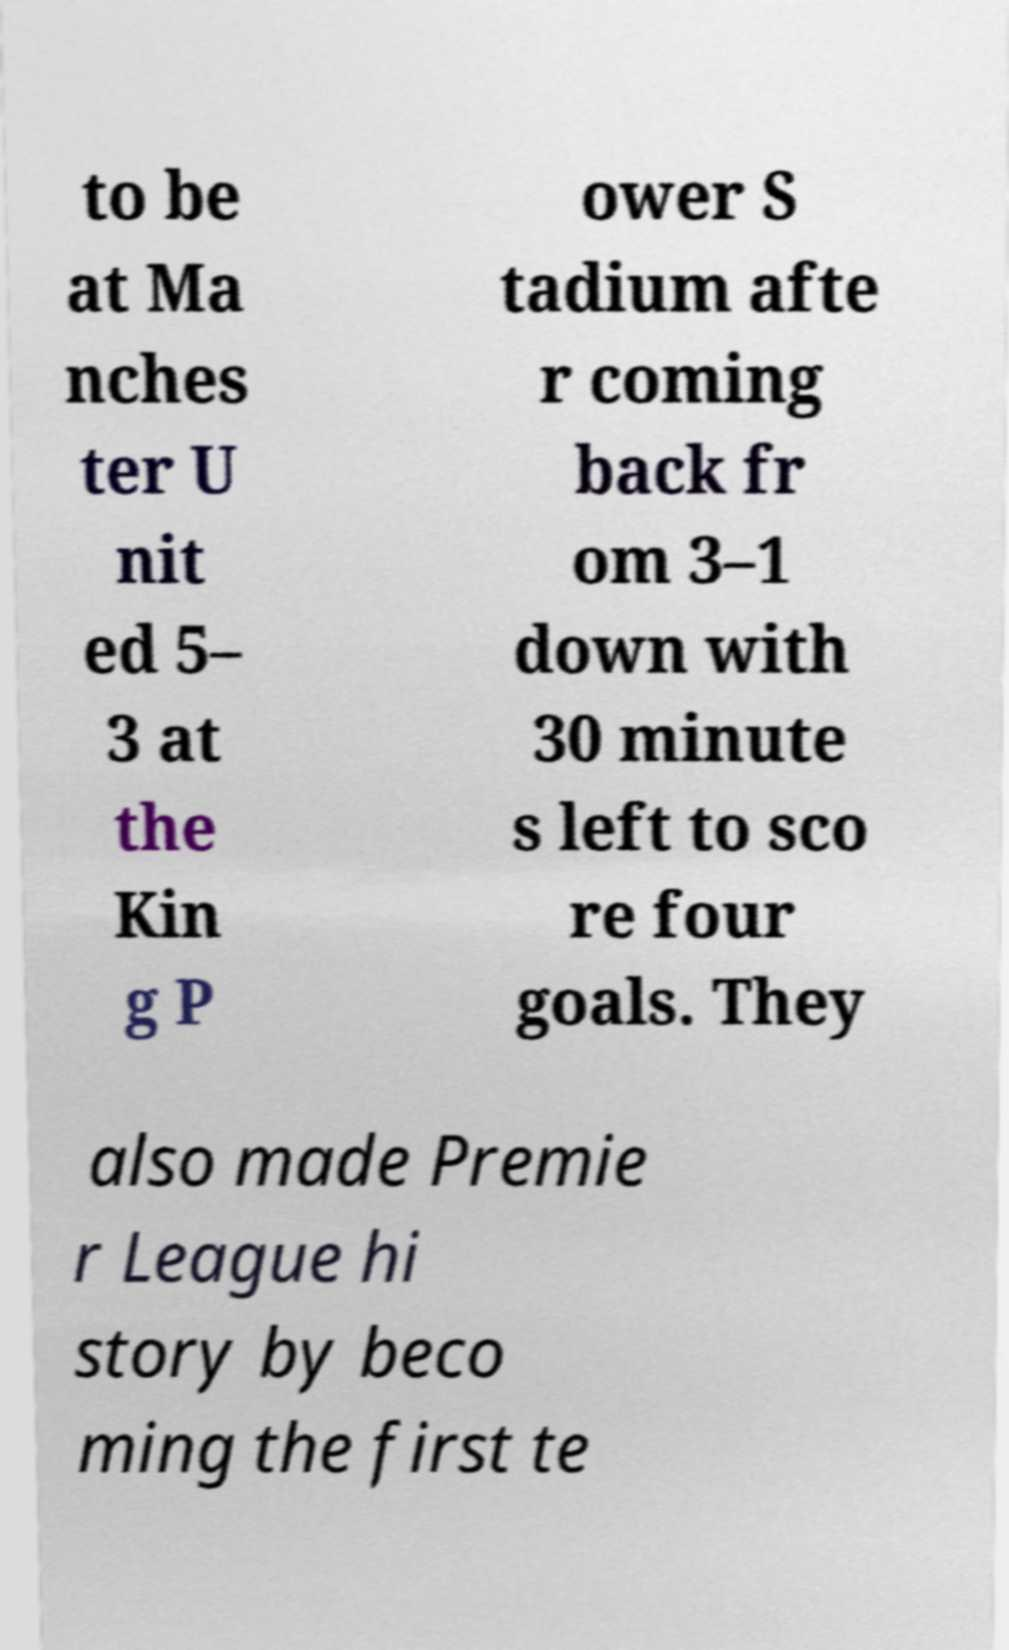Can you accurately transcribe the text from the provided image for me? to be at Ma nches ter U nit ed 5– 3 at the Kin g P ower S tadium afte r coming back fr om 3–1 down with 30 minute s left to sco re four goals. They also made Premie r League hi story by beco ming the first te 